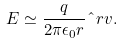Convert formula to latex. <formula><loc_0><loc_0><loc_500><loc_500>E \simeq \frac { q } { 2 \pi \epsilon _ { 0 } r } \hat { \ } r v .</formula> 